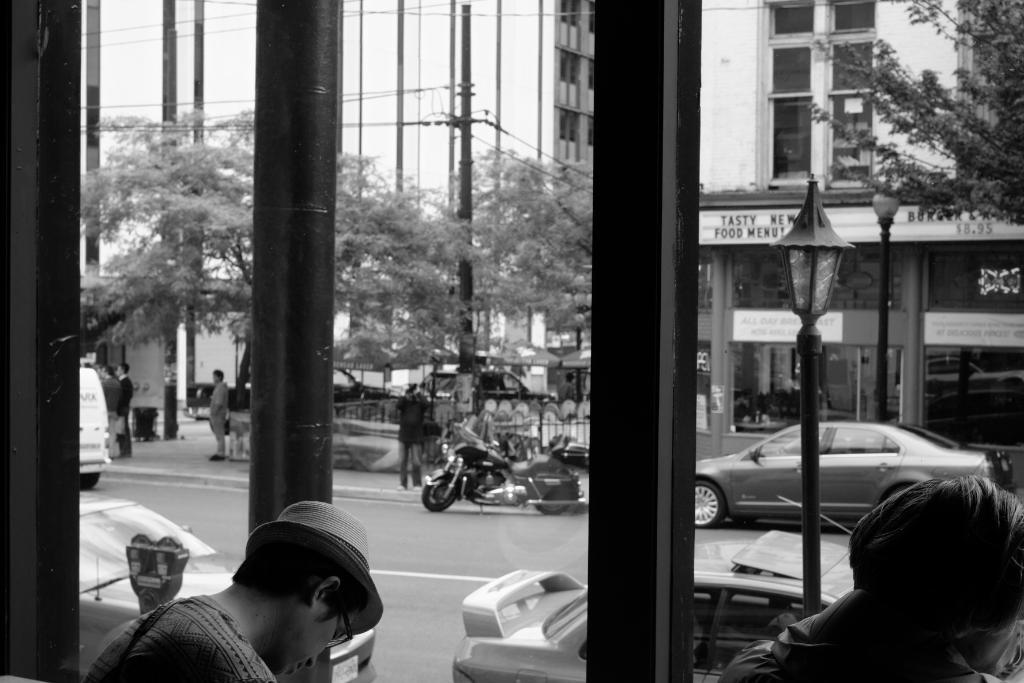How many people are present in the image? There are two persons in the image. What objects can be seen related to parking in the image? There are parking meters in the image. What type of vertical structures are present in the image? There are poles and pillars in the image. What type of illumination is visible in the image? There are lights in the image. What type of vegetation is present in the image? There are trees in the image. What type of barriers are present in the image? There are iron grills in the image. What type of man-made structures are present in the image? There are buildings in the image. What type of transportation is visible on the road in the image? There are vehicles on the road in the image. What group of people can be seen standing in the image? There is a group of people standing in the image. What type of zebra can be seen grazing on the grapes in the image? There is no zebra or grapes present in the image. What is the top of the tallest building in the image? The provided facts do not mention the height of the buildings, so we cannot determine the top of the tallest building in the image. 